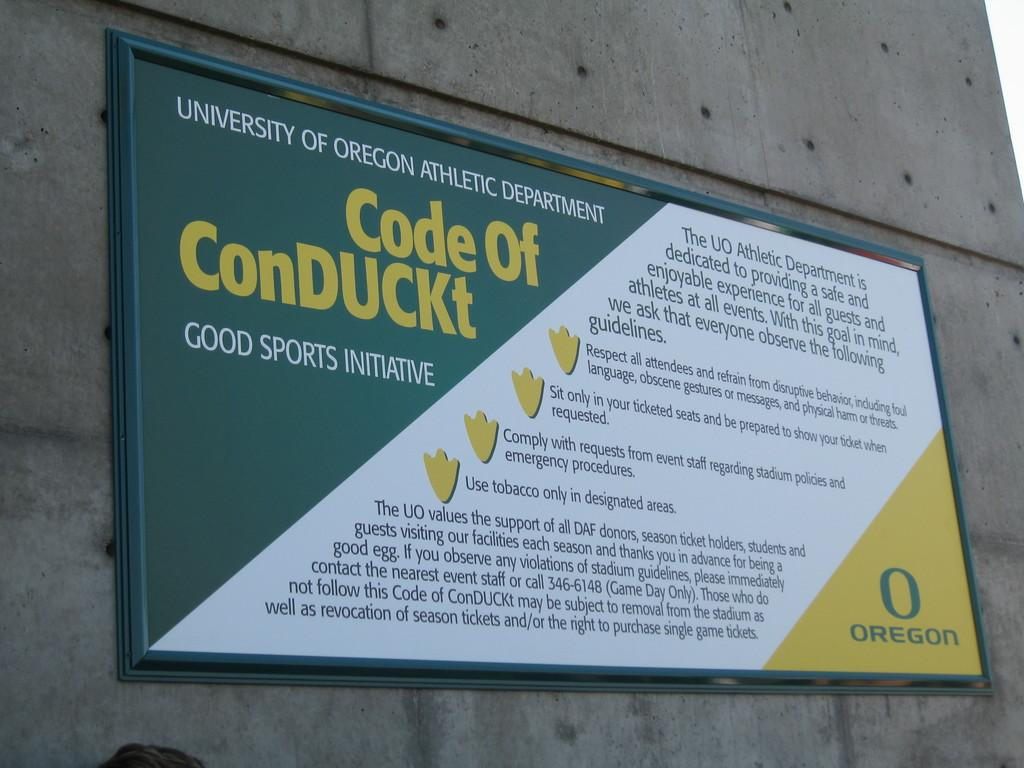<image>
Write a terse but informative summary of the picture. A sign for the University of Oregon Athletic Department displays a Code of ConDUCKt. 